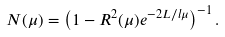Convert formula to latex. <formula><loc_0><loc_0><loc_500><loc_500>N ( \mu ) = \left ( 1 - R ^ { 2 } ( \mu ) e ^ { - 2 L / l \mu } \right ) ^ { - 1 } .</formula> 